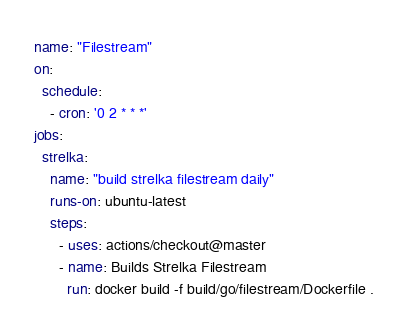<code> <loc_0><loc_0><loc_500><loc_500><_YAML_>name: "Filestream"
on:
  schedule:
    - cron: '0 2 * * *'
jobs:
  strelka:
    name: "build strelka filestream daily"
    runs-on: ubuntu-latest
    steps:
      - uses: actions/checkout@master
      - name: Builds Strelka Filestream
        run: docker build -f build/go/filestream/Dockerfile .
</code> 